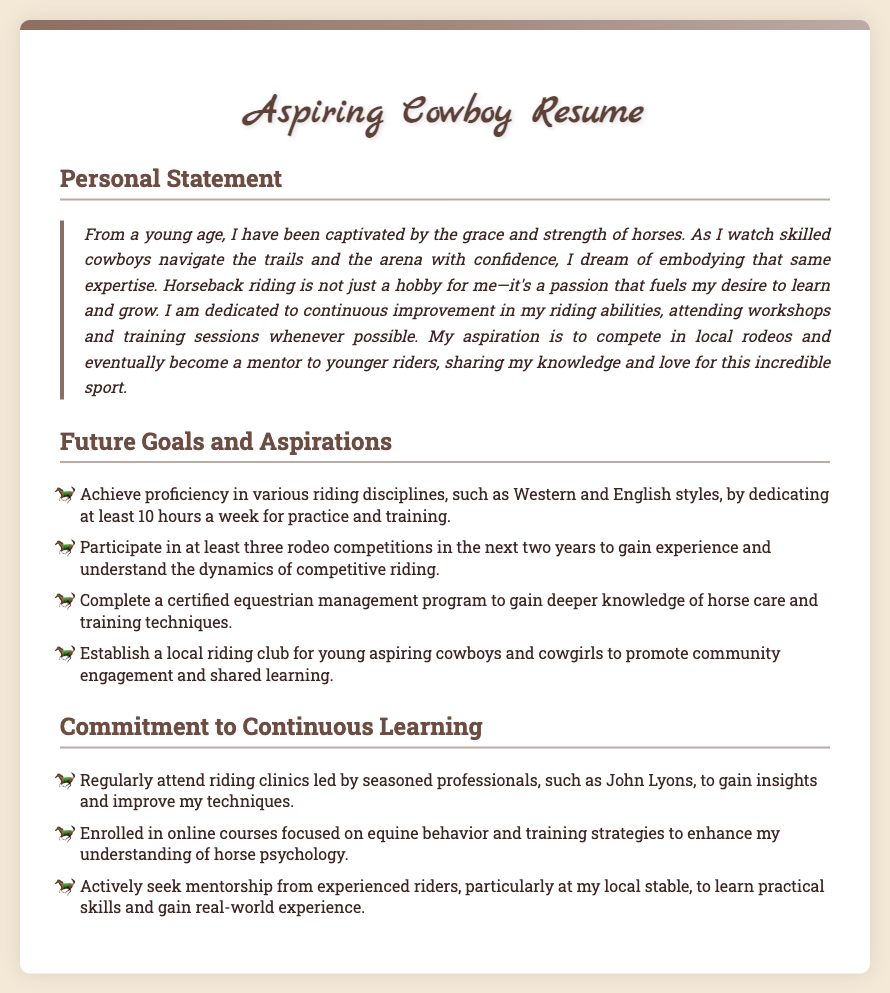What fuels the desire to learn and grow? The personal statement expresses that a passion for horseback riding fuels the desire to learn and grow.
Answer: Passion for horseback riding How many hours a week is dedicated to practice and training? The personal statement mentions dedicating at least 10 hours a week for practice and training.
Answer: 10 hours Who is the mentor mentioned for attending riding clinics? The document references attending riding clinics led by John Lyons to gain insights and improve techniques.
Answer: John Lyons What is one goal mentioned for the next two years? The goals include participating in at least three rodeo competitions in the next two years to gain experience.
Answer: Three rodeo competitions What type of program is to be completed for deeper knowledge? The future goals include completing a certified equestrian management program to gain deeper knowledge of horse care and training techniques.
Answer: Certified equestrian management program What is a future goal related to community engagement? The future goals include establishing a local riding club for young aspiring cowboys and cowgirls to promote community engagement.
Answer: Local riding club 